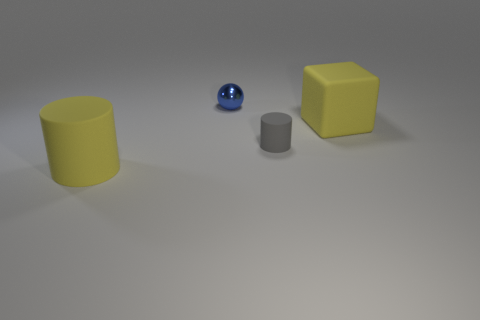Add 4 big yellow rubber objects. How many objects exist? 8 Subtract 1 cylinders. How many cylinders are left? 1 Subtract all gray cylinders. How many cylinders are left? 1 Subtract 1 yellow cubes. How many objects are left? 3 Subtract all spheres. How many objects are left? 3 Subtract all blue blocks. Subtract all green cylinders. How many blocks are left? 1 Subtract all green cylinders. How many purple cubes are left? 0 Subtract all small rubber things. Subtract all large matte things. How many objects are left? 1 Add 2 tiny blue metal things. How many tiny blue metal things are left? 3 Add 4 cyan balls. How many cyan balls exist? 4 